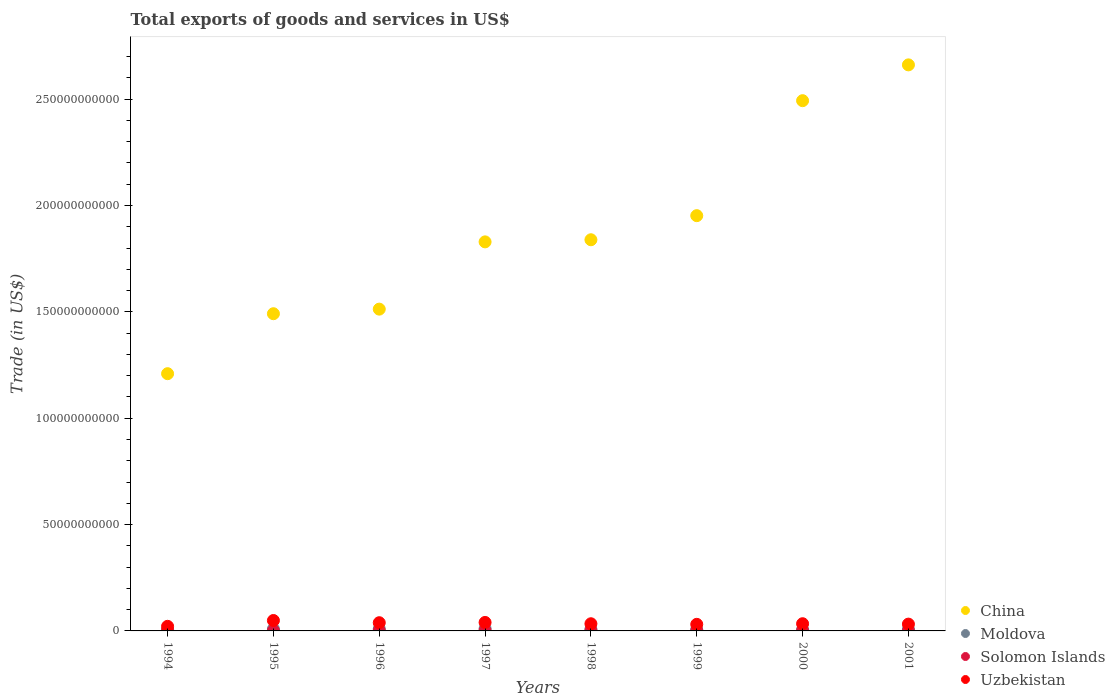Is the number of dotlines equal to the number of legend labels?
Offer a very short reply. Yes. What is the total exports of goods and services in China in 1994?
Your answer should be compact. 1.21e+11. Across all years, what is the maximum total exports of goods and services in China?
Offer a very short reply. 2.66e+11. Across all years, what is the minimum total exports of goods and services in Uzbekistan?
Provide a short and direct response. 2.16e+09. What is the total total exports of goods and services in Solomon Islands in the graph?
Provide a succinct answer. 1.29e+09. What is the difference between the total exports of goods and services in Solomon Islands in 1998 and that in 2000?
Your response must be concise. 6.57e+07. What is the difference between the total exports of goods and services in China in 1997 and the total exports of goods and services in Uzbekistan in 1995?
Offer a very short reply. 1.78e+11. What is the average total exports of goods and services in Uzbekistan per year?
Give a very brief answer. 3.50e+09. In the year 1995, what is the difference between the total exports of goods and services in Uzbekistan and total exports of goods and services in Moldova?
Give a very brief answer. 4.03e+09. In how many years, is the total exports of goods and services in China greater than 240000000000 US$?
Provide a succinct answer. 2. What is the ratio of the total exports of goods and services in Uzbekistan in 1995 to that in 1997?
Your answer should be compact. 1.23. Is the total exports of goods and services in Moldova in 1995 less than that in 1999?
Provide a short and direct response. No. Is the difference between the total exports of goods and services in Uzbekistan in 1994 and 2001 greater than the difference between the total exports of goods and services in Moldova in 1994 and 2001?
Your answer should be very brief. No. What is the difference between the highest and the second highest total exports of goods and services in Moldova?
Make the answer very short. 1.21e+08. What is the difference between the highest and the lowest total exports of goods and services in Solomon Islands?
Your response must be concise. 1.53e+08. In how many years, is the total exports of goods and services in Moldova greater than the average total exports of goods and services in Moldova taken over all years?
Provide a succinct answer. 4. Is it the case that in every year, the sum of the total exports of goods and services in China and total exports of goods and services in Moldova  is greater than the sum of total exports of goods and services in Uzbekistan and total exports of goods and services in Solomon Islands?
Make the answer very short. Yes. Is it the case that in every year, the sum of the total exports of goods and services in Moldova and total exports of goods and services in China  is greater than the total exports of goods and services in Solomon Islands?
Ensure brevity in your answer.  Yes. Does the total exports of goods and services in China monotonically increase over the years?
Your answer should be very brief. Yes. Is the total exports of goods and services in Uzbekistan strictly greater than the total exports of goods and services in Moldova over the years?
Your answer should be very brief. Yes. Is the total exports of goods and services in China strictly less than the total exports of goods and services in Moldova over the years?
Offer a very short reply. No. Does the graph contain any zero values?
Offer a terse response. No. How many legend labels are there?
Provide a succinct answer. 4. What is the title of the graph?
Your answer should be compact. Total exports of goods and services in US$. Does "Lao PDR" appear as one of the legend labels in the graph?
Provide a succinct answer. No. What is the label or title of the Y-axis?
Offer a terse response. Trade (in US$). What is the Trade (in US$) in China in 1994?
Provide a succinct answer. 1.21e+11. What is the Trade (in US$) of Moldova in 1994?
Provide a succinct answer. 6.51e+08. What is the Trade (in US$) of Solomon Islands in 1994?
Your response must be concise. 1.71e+08. What is the Trade (in US$) of Uzbekistan in 1994?
Your response must be concise. 2.16e+09. What is the Trade (in US$) of China in 1995?
Your answer should be very brief. 1.49e+11. What is the Trade (in US$) in Moldova in 1995?
Your response must be concise. 8.65e+08. What is the Trade (in US$) in Solomon Islands in 1995?
Provide a succinct answer. 1.88e+08. What is the Trade (in US$) of Uzbekistan in 1995?
Offer a terse response. 4.90e+09. What is the Trade (in US$) of China in 1996?
Offer a very short reply. 1.51e+11. What is the Trade (in US$) in Moldova in 1996?
Ensure brevity in your answer.  9.37e+08. What is the Trade (in US$) in Solomon Islands in 1996?
Provide a succinct answer. 1.95e+08. What is the Trade (in US$) in Uzbekistan in 1996?
Keep it short and to the point. 3.86e+09. What is the Trade (in US$) in China in 1997?
Your response must be concise. 1.83e+11. What is the Trade (in US$) of Moldova in 1997?
Your answer should be compact. 1.06e+09. What is the Trade (in US$) of Solomon Islands in 1997?
Give a very brief answer. 2.20e+08. What is the Trade (in US$) of Uzbekistan in 1997?
Provide a succinct answer. 3.99e+09. What is the Trade (in US$) in China in 1998?
Your answer should be very brief. 1.84e+11. What is the Trade (in US$) of Moldova in 1998?
Your answer should be compact. 7.96e+08. What is the Trade (in US$) in Solomon Islands in 1998?
Your answer should be very brief. 1.71e+08. What is the Trade (in US$) of Uzbekistan in 1998?
Make the answer very short. 3.37e+09. What is the Trade (in US$) of China in 1999?
Provide a short and direct response. 1.95e+11. What is the Trade (in US$) in Moldova in 1999?
Provide a succinct answer. 6.10e+08. What is the Trade (in US$) in Solomon Islands in 1999?
Provide a short and direct response. 1.72e+08. What is the Trade (in US$) of Uzbekistan in 1999?
Offer a very short reply. 3.10e+09. What is the Trade (in US$) of China in 2000?
Your answer should be very brief. 2.49e+11. What is the Trade (in US$) of Moldova in 2000?
Offer a terse response. 6.41e+08. What is the Trade (in US$) in Solomon Islands in 2000?
Provide a succinct answer. 1.05e+08. What is the Trade (in US$) of Uzbekistan in 2000?
Offer a terse response. 3.38e+09. What is the Trade (in US$) in China in 2001?
Your answer should be very brief. 2.66e+11. What is the Trade (in US$) in Moldova in 2001?
Provide a succinct answer. 7.38e+08. What is the Trade (in US$) of Solomon Islands in 2001?
Give a very brief answer. 6.61e+07. What is the Trade (in US$) in Uzbekistan in 2001?
Make the answer very short. 3.20e+09. Across all years, what is the maximum Trade (in US$) of China?
Provide a succinct answer. 2.66e+11. Across all years, what is the maximum Trade (in US$) of Moldova?
Provide a succinct answer. 1.06e+09. Across all years, what is the maximum Trade (in US$) in Solomon Islands?
Give a very brief answer. 2.20e+08. Across all years, what is the maximum Trade (in US$) in Uzbekistan?
Your answer should be very brief. 4.90e+09. Across all years, what is the minimum Trade (in US$) in China?
Your answer should be compact. 1.21e+11. Across all years, what is the minimum Trade (in US$) in Moldova?
Offer a terse response. 6.10e+08. Across all years, what is the minimum Trade (in US$) of Solomon Islands?
Provide a succinct answer. 6.61e+07. Across all years, what is the minimum Trade (in US$) in Uzbekistan?
Your answer should be very brief. 2.16e+09. What is the total Trade (in US$) in China in the graph?
Provide a succinct answer. 1.50e+12. What is the total Trade (in US$) in Moldova in the graph?
Give a very brief answer. 6.30e+09. What is the total Trade (in US$) of Solomon Islands in the graph?
Keep it short and to the point. 1.29e+09. What is the total Trade (in US$) of Uzbekistan in the graph?
Ensure brevity in your answer.  2.80e+1. What is the difference between the Trade (in US$) of China in 1994 and that in 1995?
Provide a succinct answer. -2.82e+1. What is the difference between the Trade (in US$) in Moldova in 1994 and that in 1995?
Your answer should be compact. -2.14e+08. What is the difference between the Trade (in US$) in Solomon Islands in 1994 and that in 1995?
Provide a short and direct response. -1.73e+07. What is the difference between the Trade (in US$) of Uzbekistan in 1994 and that in 1995?
Offer a very short reply. -2.73e+09. What is the difference between the Trade (in US$) in China in 1994 and that in 1996?
Give a very brief answer. -3.03e+1. What is the difference between the Trade (in US$) of Moldova in 1994 and that in 1996?
Offer a very short reply. -2.86e+08. What is the difference between the Trade (in US$) in Solomon Islands in 1994 and that in 1996?
Give a very brief answer. -2.37e+07. What is the difference between the Trade (in US$) of Uzbekistan in 1994 and that in 1996?
Offer a terse response. -1.70e+09. What is the difference between the Trade (in US$) in China in 1994 and that in 1997?
Offer a very short reply. -6.20e+1. What is the difference between the Trade (in US$) in Moldova in 1994 and that in 1997?
Provide a succinct answer. -4.06e+08. What is the difference between the Trade (in US$) of Solomon Islands in 1994 and that in 1997?
Your response must be concise. -4.88e+07. What is the difference between the Trade (in US$) in Uzbekistan in 1994 and that in 1997?
Make the answer very short. -1.82e+09. What is the difference between the Trade (in US$) in China in 1994 and that in 1998?
Make the answer very short. -6.30e+1. What is the difference between the Trade (in US$) in Moldova in 1994 and that in 1998?
Provide a succinct answer. -1.45e+08. What is the difference between the Trade (in US$) of Solomon Islands in 1994 and that in 1998?
Give a very brief answer. 3.00e+05. What is the difference between the Trade (in US$) in Uzbekistan in 1994 and that in 1998?
Provide a succinct answer. -1.21e+09. What is the difference between the Trade (in US$) of China in 1994 and that in 1999?
Offer a very short reply. -7.43e+1. What is the difference between the Trade (in US$) in Moldova in 1994 and that in 1999?
Provide a short and direct response. 4.12e+07. What is the difference between the Trade (in US$) in Solomon Islands in 1994 and that in 1999?
Ensure brevity in your answer.  -1.28e+06. What is the difference between the Trade (in US$) in Uzbekistan in 1994 and that in 1999?
Provide a short and direct response. -9.35e+08. What is the difference between the Trade (in US$) of China in 1994 and that in 2000?
Your answer should be very brief. -1.28e+11. What is the difference between the Trade (in US$) in Moldova in 1994 and that in 2000?
Your response must be concise. 9.64e+06. What is the difference between the Trade (in US$) of Solomon Islands in 1994 and that in 2000?
Keep it short and to the point. 6.60e+07. What is the difference between the Trade (in US$) in Uzbekistan in 1994 and that in 2000?
Provide a short and direct response. -1.22e+09. What is the difference between the Trade (in US$) in China in 1994 and that in 2001?
Offer a terse response. -1.45e+11. What is the difference between the Trade (in US$) in Moldova in 1994 and that in 2001?
Provide a short and direct response. -8.72e+07. What is the difference between the Trade (in US$) of Solomon Islands in 1994 and that in 2001?
Your answer should be compact. 1.05e+08. What is the difference between the Trade (in US$) in Uzbekistan in 1994 and that in 2001?
Give a very brief answer. -1.04e+09. What is the difference between the Trade (in US$) in China in 1995 and that in 1996?
Offer a very short reply. -2.15e+09. What is the difference between the Trade (in US$) in Moldova in 1995 and that in 1996?
Offer a terse response. -7.18e+07. What is the difference between the Trade (in US$) of Solomon Islands in 1995 and that in 1996?
Offer a terse response. -6.42e+06. What is the difference between the Trade (in US$) of Uzbekistan in 1995 and that in 1996?
Keep it short and to the point. 1.04e+09. What is the difference between the Trade (in US$) in China in 1995 and that in 1997?
Offer a terse response. -3.38e+1. What is the difference between the Trade (in US$) in Moldova in 1995 and that in 1997?
Offer a very short reply. -1.92e+08. What is the difference between the Trade (in US$) in Solomon Islands in 1995 and that in 1997?
Provide a short and direct response. -3.15e+07. What is the difference between the Trade (in US$) in Uzbekistan in 1995 and that in 1997?
Your response must be concise. 9.10e+08. What is the difference between the Trade (in US$) of China in 1995 and that in 1998?
Your answer should be very brief. -3.48e+1. What is the difference between the Trade (in US$) in Moldova in 1995 and that in 1998?
Provide a succinct answer. 6.94e+07. What is the difference between the Trade (in US$) in Solomon Islands in 1995 and that in 1998?
Offer a terse response. 1.76e+07. What is the difference between the Trade (in US$) of Uzbekistan in 1995 and that in 1998?
Provide a succinct answer. 1.53e+09. What is the difference between the Trade (in US$) in China in 1995 and that in 1999?
Offer a very short reply. -4.61e+1. What is the difference between the Trade (in US$) of Moldova in 1995 and that in 1999?
Offer a terse response. 2.55e+08. What is the difference between the Trade (in US$) of Solomon Islands in 1995 and that in 1999?
Provide a succinct answer. 1.60e+07. What is the difference between the Trade (in US$) in Uzbekistan in 1995 and that in 1999?
Keep it short and to the point. 1.80e+09. What is the difference between the Trade (in US$) in China in 1995 and that in 2000?
Ensure brevity in your answer.  -1.00e+11. What is the difference between the Trade (in US$) of Moldova in 1995 and that in 2000?
Keep it short and to the point. 2.24e+08. What is the difference between the Trade (in US$) of Solomon Islands in 1995 and that in 2000?
Provide a short and direct response. 8.33e+07. What is the difference between the Trade (in US$) of Uzbekistan in 1995 and that in 2000?
Offer a very short reply. 1.51e+09. What is the difference between the Trade (in US$) in China in 1995 and that in 2001?
Provide a succinct answer. -1.17e+11. What is the difference between the Trade (in US$) of Moldova in 1995 and that in 2001?
Your answer should be compact. 1.27e+08. What is the difference between the Trade (in US$) of Solomon Islands in 1995 and that in 2001?
Keep it short and to the point. 1.22e+08. What is the difference between the Trade (in US$) in Uzbekistan in 1995 and that in 2001?
Give a very brief answer. 1.70e+09. What is the difference between the Trade (in US$) in China in 1996 and that in 1997?
Provide a short and direct response. -3.16e+1. What is the difference between the Trade (in US$) in Moldova in 1996 and that in 1997?
Make the answer very short. -1.21e+08. What is the difference between the Trade (in US$) in Solomon Islands in 1996 and that in 1997?
Provide a short and direct response. -2.51e+07. What is the difference between the Trade (in US$) of Uzbekistan in 1996 and that in 1997?
Your response must be concise. -1.25e+08. What is the difference between the Trade (in US$) of China in 1996 and that in 1998?
Make the answer very short. -3.26e+1. What is the difference between the Trade (in US$) of Moldova in 1996 and that in 1998?
Offer a very short reply. 1.41e+08. What is the difference between the Trade (in US$) in Solomon Islands in 1996 and that in 1998?
Offer a terse response. 2.40e+07. What is the difference between the Trade (in US$) in Uzbekistan in 1996 and that in 1998?
Your response must be concise. 4.90e+08. What is the difference between the Trade (in US$) of China in 1996 and that in 1999?
Make the answer very short. -4.39e+1. What is the difference between the Trade (in US$) of Moldova in 1996 and that in 1999?
Provide a short and direct response. 3.27e+08. What is the difference between the Trade (in US$) of Solomon Islands in 1996 and that in 1999?
Ensure brevity in your answer.  2.24e+07. What is the difference between the Trade (in US$) in Uzbekistan in 1996 and that in 1999?
Offer a very short reply. 7.63e+08. What is the difference between the Trade (in US$) in China in 1996 and that in 2000?
Offer a very short reply. -9.80e+1. What is the difference between the Trade (in US$) in Moldova in 1996 and that in 2000?
Provide a short and direct response. 2.95e+08. What is the difference between the Trade (in US$) in Solomon Islands in 1996 and that in 2000?
Provide a short and direct response. 8.97e+07. What is the difference between the Trade (in US$) of Uzbekistan in 1996 and that in 2000?
Offer a terse response. 4.79e+08. What is the difference between the Trade (in US$) in China in 1996 and that in 2001?
Make the answer very short. -1.15e+11. What is the difference between the Trade (in US$) of Moldova in 1996 and that in 2001?
Ensure brevity in your answer.  1.99e+08. What is the difference between the Trade (in US$) in Solomon Islands in 1996 and that in 2001?
Your answer should be very brief. 1.28e+08. What is the difference between the Trade (in US$) of Uzbekistan in 1996 and that in 2001?
Your response must be concise. 6.61e+08. What is the difference between the Trade (in US$) of China in 1997 and that in 1998?
Offer a very short reply. -9.96e+08. What is the difference between the Trade (in US$) of Moldova in 1997 and that in 1998?
Your response must be concise. 2.62e+08. What is the difference between the Trade (in US$) of Solomon Islands in 1997 and that in 1998?
Ensure brevity in your answer.  4.91e+07. What is the difference between the Trade (in US$) in Uzbekistan in 1997 and that in 1998?
Provide a short and direct response. 6.15e+08. What is the difference between the Trade (in US$) in China in 1997 and that in 1999?
Provide a short and direct response. -1.23e+1. What is the difference between the Trade (in US$) of Moldova in 1997 and that in 1999?
Your answer should be very brief. 4.48e+08. What is the difference between the Trade (in US$) of Solomon Islands in 1997 and that in 1999?
Your answer should be compact. 4.75e+07. What is the difference between the Trade (in US$) of Uzbekistan in 1997 and that in 1999?
Your answer should be very brief. 8.88e+08. What is the difference between the Trade (in US$) of China in 1997 and that in 2000?
Your response must be concise. -6.64e+1. What is the difference between the Trade (in US$) of Moldova in 1997 and that in 2000?
Your answer should be compact. 4.16e+08. What is the difference between the Trade (in US$) in Solomon Islands in 1997 and that in 2000?
Offer a terse response. 1.15e+08. What is the difference between the Trade (in US$) of Uzbekistan in 1997 and that in 2000?
Ensure brevity in your answer.  6.04e+08. What is the difference between the Trade (in US$) of China in 1997 and that in 2001?
Keep it short and to the point. -8.32e+1. What is the difference between the Trade (in US$) of Moldova in 1997 and that in 2001?
Your response must be concise. 3.19e+08. What is the difference between the Trade (in US$) of Solomon Islands in 1997 and that in 2001?
Your answer should be compact. 1.53e+08. What is the difference between the Trade (in US$) of Uzbekistan in 1997 and that in 2001?
Ensure brevity in your answer.  7.86e+08. What is the difference between the Trade (in US$) of China in 1998 and that in 1999?
Keep it short and to the point. -1.13e+1. What is the difference between the Trade (in US$) of Moldova in 1998 and that in 1999?
Ensure brevity in your answer.  1.86e+08. What is the difference between the Trade (in US$) in Solomon Islands in 1998 and that in 1999?
Provide a short and direct response. -1.58e+06. What is the difference between the Trade (in US$) in Uzbekistan in 1998 and that in 1999?
Offer a terse response. 2.73e+08. What is the difference between the Trade (in US$) of China in 1998 and that in 2000?
Provide a succinct answer. -6.54e+1. What is the difference between the Trade (in US$) of Moldova in 1998 and that in 2000?
Offer a very short reply. 1.54e+08. What is the difference between the Trade (in US$) of Solomon Islands in 1998 and that in 2000?
Offer a terse response. 6.57e+07. What is the difference between the Trade (in US$) of Uzbekistan in 1998 and that in 2000?
Ensure brevity in your answer.  -1.14e+07. What is the difference between the Trade (in US$) of China in 1998 and that in 2001?
Ensure brevity in your answer.  -8.22e+1. What is the difference between the Trade (in US$) in Moldova in 1998 and that in 2001?
Give a very brief answer. 5.75e+07. What is the difference between the Trade (in US$) in Solomon Islands in 1998 and that in 2001?
Your answer should be very brief. 1.04e+08. What is the difference between the Trade (in US$) in Uzbekistan in 1998 and that in 2001?
Provide a succinct answer. 1.71e+08. What is the difference between the Trade (in US$) of China in 1999 and that in 2000?
Make the answer very short. -5.40e+1. What is the difference between the Trade (in US$) of Moldova in 1999 and that in 2000?
Offer a very short reply. -3.15e+07. What is the difference between the Trade (in US$) of Solomon Islands in 1999 and that in 2000?
Offer a terse response. 6.73e+07. What is the difference between the Trade (in US$) of Uzbekistan in 1999 and that in 2000?
Your answer should be very brief. -2.84e+08. What is the difference between the Trade (in US$) of China in 1999 and that in 2001?
Provide a short and direct response. -7.09e+1. What is the difference between the Trade (in US$) of Moldova in 1999 and that in 2001?
Ensure brevity in your answer.  -1.28e+08. What is the difference between the Trade (in US$) of Solomon Islands in 1999 and that in 2001?
Make the answer very short. 1.06e+08. What is the difference between the Trade (in US$) of Uzbekistan in 1999 and that in 2001?
Provide a short and direct response. -1.02e+08. What is the difference between the Trade (in US$) in China in 2000 and that in 2001?
Give a very brief answer. -1.68e+1. What is the difference between the Trade (in US$) of Moldova in 2000 and that in 2001?
Provide a succinct answer. -9.68e+07. What is the difference between the Trade (in US$) in Solomon Islands in 2000 and that in 2001?
Your answer should be very brief. 3.87e+07. What is the difference between the Trade (in US$) of Uzbekistan in 2000 and that in 2001?
Your answer should be compact. 1.82e+08. What is the difference between the Trade (in US$) in China in 1994 and the Trade (in US$) in Moldova in 1995?
Provide a short and direct response. 1.20e+11. What is the difference between the Trade (in US$) of China in 1994 and the Trade (in US$) of Solomon Islands in 1995?
Give a very brief answer. 1.21e+11. What is the difference between the Trade (in US$) in China in 1994 and the Trade (in US$) in Uzbekistan in 1995?
Give a very brief answer. 1.16e+11. What is the difference between the Trade (in US$) in Moldova in 1994 and the Trade (in US$) in Solomon Islands in 1995?
Give a very brief answer. 4.63e+08. What is the difference between the Trade (in US$) in Moldova in 1994 and the Trade (in US$) in Uzbekistan in 1995?
Offer a terse response. -4.25e+09. What is the difference between the Trade (in US$) in Solomon Islands in 1994 and the Trade (in US$) in Uzbekistan in 1995?
Make the answer very short. -4.73e+09. What is the difference between the Trade (in US$) in China in 1994 and the Trade (in US$) in Moldova in 1996?
Your answer should be very brief. 1.20e+11. What is the difference between the Trade (in US$) of China in 1994 and the Trade (in US$) of Solomon Islands in 1996?
Give a very brief answer. 1.21e+11. What is the difference between the Trade (in US$) in China in 1994 and the Trade (in US$) in Uzbekistan in 1996?
Give a very brief answer. 1.17e+11. What is the difference between the Trade (in US$) of Moldova in 1994 and the Trade (in US$) of Solomon Islands in 1996?
Give a very brief answer. 4.56e+08. What is the difference between the Trade (in US$) of Moldova in 1994 and the Trade (in US$) of Uzbekistan in 1996?
Your answer should be very brief. -3.21e+09. What is the difference between the Trade (in US$) in Solomon Islands in 1994 and the Trade (in US$) in Uzbekistan in 1996?
Your answer should be very brief. -3.69e+09. What is the difference between the Trade (in US$) in China in 1994 and the Trade (in US$) in Moldova in 1997?
Offer a very short reply. 1.20e+11. What is the difference between the Trade (in US$) in China in 1994 and the Trade (in US$) in Solomon Islands in 1997?
Your answer should be compact. 1.21e+11. What is the difference between the Trade (in US$) of China in 1994 and the Trade (in US$) of Uzbekistan in 1997?
Your response must be concise. 1.17e+11. What is the difference between the Trade (in US$) in Moldova in 1994 and the Trade (in US$) in Solomon Islands in 1997?
Offer a terse response. 4.31e+08. What is the difference between the Trade (in US$) in Moldova in 1994 and the Trade (in US$) in Uzbekistan in 1997?
Provide a short and direct response. -3.34e+09. What is the difference between the Trade (in US$) of Solomon Islands in 1994 and the Trade (in US$) of Uzbekistan in 1997?
Your response must be concise. -3.82e+09. What is the difference between the Trade (in US$) in China in 1994 and the Trade (in US$) in Moldova in 1998?
Provide a short and direct response. 1.20e+11. What is the difference between the Trade (in US$) in China in 1994 and the Trade (in US$) in Solomon Islands in 1998?
Offer a very short reply. 1.21e+11. What is the difference between the Trade (in US$) of China in 1994 and the Trade (in US$) of Uzbekistan in 1998?
Ensure brevity in your answer.  1.18e+11. What is the difference between the Trade (in US$) of Moldova in 1994 and the Trade (in US$) of Solomon Islands in 1998?
Provide a short and direct response. 4.80e+08. What is the difference between the Trade (in US$) of Moldova in 1994 and the Trade (in US$) of Uzbekistan in 1998?
Ensure brevity in your answer.  -2.72e+09. What is the difference between the Trade (in US$) of Solomon Islands in 1994 and the Trade (in US$) of Uzbekistan in 1998?
Your answer should be compact. -3.20e+09. What is the difference between the Trade (in US$) in China in 1994 and the Trade (in US$) in Moldova in 1999?
Provide a short and direct response. 1.20e+11. What is the difference between the Trade (in US$) in China in 1994 and the Trade (in US$) in Solomon Islands in 1999?
Keep it short and to the point. 1.21e+11. What is the difference between the Trade (in US$) of China in 1994 and the Trade (in US$) of Uzbekistan in 1999?
Ensure brevity in your answer.  1.18e+11. What is the difference between the Trade (in US$) in Moldova in 1994 and the Trade (in US$) in Solomon Islands in 1999?
Offer a very short reply. 4.79e+08. What is the difference between the Trade (in US$) in Moldova in 1994 and the Trade (in US$) in Uzbekistan in 1999?
Offer a terse response. -2.45e+09. What is the difference between the Trade (in US$) of Solomon Islands in 1994 and the Trade (in US$) of Uzbekistan in 1999?
Keep it short and to the point. -2.93e+09. What is the difference between the Trade (in US$) in China in 1994 and the Trade (in US$) in Moldova in 2000?
Your response must be concise. 1.20e+11. What is the difference between the Trade (in US$) in China in 1994 and the Trade (in US$) in Solomon Islands in 2000?
Provide a succinct answer. 1.21e+11. What is the difference between the Trade (in US$) of China in 1994 and the Trade (in US$) of Uzbekistan in 2000?
Your response must be concise. 1.18e+11. What is the difference between the Trade (in US$) of Moldova in 1994 and the Trade (in US$) of Solomon Islands in 2000?
Make the answer very short. 5.46e+08. What is the difference between the Trade (in US$) of Moldova in 1994 and the Trade (in US$) of Uzbekistan in 2000?
Offer a very short reply. -2.73e+09. What is the difference between the Trade (in US$) of Solomon Islands in 1994 and the Trade (in US$) of Uzbekistan in 2000?
Keep it short and to the point. -3.21e+09. What is the difference between the Trade (in US$) of China in 1994 and the Trade (in US$) of Moldova in 2001?
Provide a short and direct response. 1.20e+11. What is the difference between the Trade (in US$) in China in 1994 and the Trade (in US$) in Solomon Islands in 2001?
Offer a terse response. 1.21e+11. What is the difference between the Trade (in US$) in China in 1994 and the Trade (in US$) in Uzbekistan in 2001?
Provide a succinct answer. 1.18e+11. What is the difference between the Trade (in US$) of Moldova in 1994 and the Trade (in US$) of Solomon Islands in 2001?
Provide a short and direct response. 5.85e+08. What is the difference between the Trade (in US$) of Moldova in 1994 and the Trade (in US$) of Uzbekistan in 2001?
Keep it short and to the point. -2.55e+09. What is the difference between the Trade (in US$) of Solomon Islands in 1994 and the Trade (in US$) of Uzbekistan in 2001?
Give a very brief answer. -3.03e+09. What is the difference between the Trade (in US$) in China in 1995 and the Trade (in US$) in Moldova in 1996?
Give a very brief answer. 1.48e+11. What is the difference between the Trade (in US$) in China in 1995 and the Trade (in US$) in Solomon Islands in 1996?
Ensure brevity in your answer.  1.49e+11. What is the difference between the Trade (in US$) in China in 1995 and the Trade (in US$) in Uzbekistan in 1996?
Provide a short and direct response. 1.45e+11. What is the difference between the Trade (in US$) in Moldova in 1995 and the Trade (in US$) in Solomon Islands in 1996?
Your answer should be very brief. 6.70e+08. What is the difference between the Trade (in US$) in Moldova in 1995 and the Trade (in US$) in Uzbekistan in 1996?
Your response must be concise. -3.00e+09. What is the difference between the Trade (in US$) of Solomon Islands in 1995 and the Trade (in US$) of Uzbekistan in 1996?
Offer a terse response. -3.67e+09. What is the difference between the Trade (in US$) in China in 1995 and the Trade (in US$) in Moldova in 1997?
Your answer should be very brief. 1.48e+11. What is the difference between the Trade (in US$) of China in 1995 and the Trade (in US$) of Solomon Islands in 1997?
Keep it short and to the point. 1.49e+11. What is the difference between the Trade (in US$) of China in 1995 and the Trade (in US$) of Uzbekistan in 1997?
Offer a very short reply. 1.45e+11. What is the difference between the Trade (in US$) in Moldova in 1995 and the Trade (in US$) in Solomon Islands in 1997?
Your response must be concise. 6.45e+08. What is the difference between the Trade (in US$) in Moldova in 1995 and the Trade (in US$) in Uzbekistan in 1997?
Offer a terse response. -3.12e+09. What is the difference between the Trade (in US$) in Solomon Islands in 1995 and the Trade (in US$) in Uzbekistan in 1997?
Make the answer very short. -3.80e+09. What is the difference between the Trade (in US$) in China in 1995 and the Trade (in US$) in Moldova in 1998?
Your answer should be compact. 1.48e+11. What is the difference between the Trade (in US$) of China in 1995 and the Trade (in US$) of Solomon Islands in 1998?
Give a very brief answer. 1.49e+11. What is the difference between the Trade (in US$) of China in 1995 and the Trade (in US$) of Uzbekistan in 1998?
Your response must be concise. 1.46e+11. What is the difference between the Trade (in US$) in Moldova in 1995 and the Trade (in US$) in Solomon Islands in 1998?
Provide a short and direct response. 6.95e+08. What is the difference between the Trade (in US$) in Moldova in 1995 and the Trade (in US$) in Uzbekistan in 1998?
Ensure brevity in your answer.  -2.51e+09. What is the difference between the Trade (in US$) of Solomon Islands in 1995 and the Trade (in US$) of Uzbekistan in 1998?
Provide a short and direct response. -3.18e+09. What is the difference between the Trade (in US$) in China in 1995 and the Trade (in US$) in Moldova in 1999?
Provide a succinct answer. 1.49e+11. What is the difference between the Trade (in US$) of China in 1995 and the Trade (in US$) of Solomon Islands in 1999?
Your answer should be very brief. 1.49e+11. What is the difference between the Trade (in US$) of China in 1995 and the Trade (in US$) of Uzbekistan in 1999?
Ensure brevity in your answer.  1.46e+11. What is the difference between the Trade (in US$) in Moldova in 1995 and the Trade (in US$) in Solomon Islands in 1999?
Make the answer very short. 6.93e+08. What is the difference between the Trade (in US$) in Moldova in 1995 and the Trade (in US$) in Uzbekistan in 1999?
Keep it short and to the point. -2.23e+09. What is the difference between the Trade (in US$) of Solomon Islands in 1995 and the Trade (in US$) of Uzbekistan in 1999?
Provide a short and direct response. -2.91e+09. What is the difference between the Trade (in US$) in China in 1995 and the Trade (in US$) in Moldova in 2000?
Provide a short and direct response. 1.48e+11. What is the difference between the Trade (in US$) of China in 1995 and the Trade (in US$) of Solomon Islands in 2000?
Provide a succinct answer. 1.49e+11. What is the difference between the Trade (in US$) of China in 1995 and the Trade (in US$) of Uzbekistan in 2000?
Provide a succinct answer. 1.46e+11. What is the difference between the Trade (in US$) in Moldova in 1995 and the Trade (in US$) in Solomon Islands in 2000?
Ensure brevity in your answer.  7.60e+08. What is the difference between the Trade (in US$) of Moldova in 1995 and the Trade (in US$) of Uzbekistan in 2000?
Keep it short and to the point. -2.52e+09. What is the difference between the Trade (in US$) of Solomon Islands in 1995 and the Trade (in US$) of Uzbekistan in 2000?
Keep it short and to the point. -3.20e+09. What is the difference between the Trade (in US$) of China in 1995 and the Trade (in US$) of Moldova in 2001?
Offer a very short reply. 1.48e+11. What is the difference between the Trade (in US$) of China in 1995 and the Trade (in US$) of Solomon Islands in 2001?
Offer a very short reply. 1.49e+11. What is the difference between the Trade (in US$) in China in 1995 and the Trade (in US$) in Uzbekistan in 2001?
Your answer should be very brief. 1.46e+11. What is the difference between the Trade (in US$) of Moldova in 1995 and the Trade (in US$) of Solomon Islands in 2001?
Ensure brevity in your answer.  7.99e+08. What is the difference between the Trade (in US$) in Moldova in 1995 and the Trade (in US$) in Uzbekistan in 2001?
Provide a short and direct response. -2.34e+09. What is the difference between the Trade (in US$) in Solomon Islands in 1995 and the Trade (in US$) in Uzbekistan in 2001?
Keep it short and to the point. -3.01e+09. What is the difference between the Trade (in US$) of China in 1996 and the Trade (in US$) of Moldova in 1997?
Your answer should be very brief. 1.50e+11. What is the difference between the Trade (in US$) in China in 1996 and the Trade (in US$) in Solomon Islands in 1997?
Keep it short and to the point. 1.51e+11. What is the difference between the Trade (in US$) of China in 1996 and the Trade (in US$) of Uzbekistan in 1997?
Provide a succinct answer. 1.47e+11. What is the difference between the Trade (in US$) in Moldova in 1996 and the Trade (in US$) in Solomon Islands in 1997?
Your answer should be compact. 7.17e+08. What is the difference between the Trade (in US$) of Moldova in 1996 and the Trade (in US$) of Uzbekistan in 1997?
Make the answer very short. -3.05e+09. What is the difference between the Trade (in US$) of Solomon Islands in 1996 and the Trade (in US$) of Uzbekistan in 1997?
Ensure brevity in your answer.  -3.79e+09. What is the difference between the Trade (in US$) in China in 1996 and the Trade (in US$) in Moldova in 1998?
Provide a short and direct response. 1.50e+11. What is the difference between the Trade (in US$) in China in 1996 and the Trade (in US$) in Solomon Islands in 1998?
Provide a succinct answer. 1.51e+11. What is the difference between the Trade (in US$) in China in 1996 and the Trade (in US$) in Uzbekistan in 1998?
Offer a very short reply. 1.48e+11. What is the difference between the Trade (in US$) of Moldova in 1996 and the Trade (in US$) of Solomon Islands in 1998?
Offer a terse response. 7.66e+08. What is the difference between the Trade (in US$) in Moldova in 1996 and the Trade (in US$) in Uzbekistan in 1998?
Offer a terse response. -2.44e+09. What is the difference between the Trade (in US$) of Solomon Islands in 1996 and the Trade (in US$) of Uzbekistan in 1998?
Offer a very short reply. -3.18e+09. What is the difference between the Trade (in US$) of China in 1996 and the Trade (in US$) of Moldova in 1999?
Your answer should be compact. 1.51e+11. What is the difference between the Trade (in US$) in China in 1996 and the Trade (in US$) in Solomon Islands in 1999?
Your answer should be very brief. 1.51e+11. What is the difference between the Trade (in US$) of China in 1996 and the Trade (in US$) of Uzbekistan in 1999?
Keep it short and to the point. 1.48e+11. What is the difference between the Trade (in US$) in Moldova in 1996 and the Trade (in US$) in Solomon Islands in 1999?
Provide a succinct answer. 7.65e+08. What is the difference between the Trade (in US$) of Moldova in 1996 and the Trade (in US$) of Uzbekistan in 1999?
Keep it short and to the point. -2.16e+09. What is the difference between the Trade (in US$) of Solomon Islands in 1996 and the Trade (in US$) of Uzbekistan in 1999?
Provide a succinct answer. -2.90e+09. What is the difference between the Trade (in US$) in China in 1996 and the Trade (in US$) in Moldova in 2000?
Offer a very short reply. 1.51e+11. What is the difference between the Trade (in US$) of China in 1996 and the Trade (in US$) of Solomon Islands in 2000?
Your response must be concise. 1.51e+11. What is the difference between the Trade (in US$) of China in 1996 and the Trade (in US$) of Uzbekistan in 2000?
Ensure brevity in your answer.  1.48e+11. What is the difference between the Trade (in US$) of Moldova in 1996 and the Trade (in US$) of Solomon Islands in 2000?
Ensure brevity in your answer.  8.32e+08. What is the difference between the Trade (in US$) in Moldova in 1996 and the Trade (in US$) in Uzbekistan in 2000?
Give a very brief answer. -2.45e+09. What is the difference between the Trade (in US$) of Solomon Islands in 1996 and the Trade (in US$) of Uzbekistan in 2000?
Keep it short and to the point. -3.19e+09. What is the difference between the Trade (in US$) of China in 1996 and the Trade (in US$) of Moldova in 2001?
Your response must be concise. 1.51e+11. What is the difference between the Trade (in US$) of China in 1996 and the Trade (in US$) of Solomon Islands in 2001?
Your answer should be compact. 1.51e+11. What is the difference between the Trade (in US$) of China in 1996 and the Trade (in US$) of Uzbekistan in 2001?
Your answer should be compact. 1.48e+11. What is the difference between the Trade (in US$) of Moldova in 1996 and the Trade (in US$) of Solomon Islands in 2001?
Your answer should be very brief. 8.71e+08. What is the difference between the Trade (in US$) in Moldova in 1996 and the Trade (in US$) in Uzbekistan in 2001?
Offer a terse response. -2.26e+09. What is the difference between the Trade (in US$) of Solomon Islands in 1996 and the Trade (in US$) of Uzbekistan in 2001?
Provide a short and direct response. -3.01e+09. What is the difference between the Trade (in US$) of China in 1997 and the Trade (in US$) of Moldova in 1998?
Your answer should be very brief. 1.82e+11. What is the difference between the Trade (in US$) in China in 1997 and the Trade (in US$) in Solomon Islands in 1998?
Give a very brief answer. 1.83e+11. What is the difference between the Trade (in US$) in China in 1997 and the Trade (in US$) in Uzbekistan in 1998?
Your response must be concise. 1.80e+11. What is the difference between the Trade (in US$) in Moldova in 1997 and the Trade (in US$) in Solomon Islands in 1998?
Give a very brief answer. 8.87e+08. What is the difference between the Trade (in US$) in Moldova in 1997 and the Trade (in US$) in Uzbekistan in 1998?
Your response must be concise. -2.31e+09. What is the difference between the Trade (in US$) in Solomon Islands in 1997 and the Trade (in US$) in Uzbekistan in 1998?
Give a very brief answer. -3.15e+09. What is the difference between the Trade (in US$) of China in 1997 and the Trade (in US$) of Moldova in 1999?
Your answer should be very brief. 1.82e+11. What is the difference between the Trade (in US$) in China in 1997 and the Trade (in US$) in Solomon Islands in 1999?
Offer a very short reply. 1.83e+11. What is the difference between the Trade (in US$) in China in 1997 and the Trade (in US$) in Uzbekistan in 1999?
Offer a terse response. 1.80e+11. What is the difference between the Trade (in US$) of Moldova in 1997 and the Trade (in US$) of Solomon Islands in 1999?
Your response must be concise. 8.85e+08. What is the difference between the Trade (in US$) of Moldova in 1997 and the Trade (in US$) of Uzbekistan in 1999?
Provide a succinct answer. -2.04e+09. What is the difference between the Trade (in US$) of Solomon Islands in 1997 and the Trade (in US$) of Uzbekistan in 1999?
Provide a succinct answer. -2.88e+09. What is the difference between the Trade (in US$) in China in 1997 and the Trade (in US$) in Moldova in 2000?
Make the answer very short. 1.82e+11. What is the difference between the Trade (in US$) of China in 1997 and the Trade (in US$) of Solomon Islands in 2000?
Provide a succinct answer. 1.83e+11. What is the difference between the Trade (in US$) in China in 1997 and the Trade (in US$) in Uzbekistan in 2000?
Keep it short and to the point. 1.80e+11. What is the difference between the Trade (in US$) in Moldova in 1997 and the Trade (in US$) in Solomon Islands in 2000?
Your response must be concise. 9.53e+08. What is the difference between the Trade (in US$) in Moldova in 1997 and the Trade (in US$) in Uzbekistan in 2000?
Provide a short and direct response. -2.33e+09. What is the difference between the Trade (in US$) of Solomon Islands in 1997 and the Trade (in US$) of Uzbekistan in 2000?
Make the answer very short. -3.16e+09. What is the difference between the Trade (in US$) of China in 1997 and the Trade (in US$) of Moldova in 2001?
Your answer should be compact. 1.82e+11. What is the difference between the Trade (in US$) in China in 1997 and the Trade (in US$) in Solomon Islands in 2001?
Ensure brevity in your answer.  1.83e+11. What is the difference between the Trade (in US$) in China in 1997 and the Trade (in US$) in Uzbekistan in 2001?
Provide a succinct answer. 1.80e+11. What is the difference between the Trade (in US$) in Moldova in 1997 and the Trade (in US$) in Solomon Islands in 2001?
Your response must be concise. 9.91e+08. What is the difference between the Trade (in US$) of Moldova in 1997 and the Trade (in US$) of Uzbekistan in 2001?
Offer a terse response. -2.14e+09. What is the difference between the Trade (in US$) in Solomon Islands in 1997 and the Trade (in US$) in Uzbekistan in 2001?
Your answer should be very brief. -2.98e+09. What is the difference between the Trade (in US$) in China in 1998 and the Trade (in US$) in Moldova in 1999?
Give a very brief answer. 1.83e+11. What is the difference between the Trade (in US$) of China in 1998 and the Trade (in US$) of Solomon Islands in 1999?
Give a very brief answer. 1.84e+11. What is the difference between the Trade (in US$) in China in 1998 and the Trade (in US$) in Uzbekistan in 1999?
Give a very brief answer. 1.81e+11. What is the difference between the Trade (in US$) in Moldova in 1998 and the Trade (in US$) in Solomon Islands in 1999?
Offer a very short reply. 6.24e+08. What is the difference between the Trade (in US$) of Moldova in 1998 and the Trade (in US$) of Uzbekistan in 1999?
Your answer should be very brief. -2.30e+09. What is the difference between the Trade (in US$) in Solomon Islands in 1998 and the Trade (in US$) in Uzbekistan in 1999?
Your answer should be very brief. -2.93e+09. What is the difference between the Trade (in US$) of China in 1998 and the Trade (in US$) of Moldova in 2000?
Offer a very short reply. 1.83e+11. What is the difference between the Trade (in US$) in China in 1998 and the Trade (in US$) in Solomon Islands in 2000?
Give a very brief answer. 1.84e+11. What is the difference between the Trade (in US$) of China in 1998 and the Trade (in US$) of Uzbekistan in 2000?
Ensure brevity in your answer.  1.80e+11. What is the difference between the Trade (in US$) in Moldova in 1998 and the Trade (in US$) in Solomon Islands in 2000?
Offer a very short reply. 6.91e+08. What is the difference between the Trade (in US$) of Moldova in 1998 and the Trade (in US$) of Uzbekistan in 2000?
Offer a very short reply. -2.59e+09. What is the difference between the Trade (in US$) of Solomon Islands in 1998 and the Trade (in US$) of Uzbekistan in 2000?
Your response must be concise. -3.21e+09. What is the difference between the Trade (in US$) in China in 1998 and the Trade (in US$) in Moldova in 2001?
Keep it short and to the point. 1.83e+11. What is the difference between the Trade (in US$) in China in 1998 and the Trade (in US$) in Solomon Islands in 2001?
Provide a short and direct response. 1.84e+11. What is the difference between the Trade (in US$) of China in 1998 and the Trade (in US$) of Uzbekistan in 2001?
Ensure brevity in your answer.  1.81e+11. What is the difference between the Trade (in US$) in Moldova in 1998 and the Trade (in US$) in Solomon Islands in 2001?
Offer a terse response. 7.29e+08. What is the difference between the Trade (in US$) of Moldova in 1998 and the Trade (in US$) of Uzbekistan in 2001?
Offer a terse response. -2.41e+09. What is the difference between the Trade (in US$) of Solomon Islands in 1998 and the Trade (in US$) of Uzbekistan in 2001?
Your response must be concise. -3.03e+09. What is the difference between the Trade (in US$) in China in 1999 and the Trade (in US$) in Moldova in 2000?
Your answer should be very brief. 1.95e+11. What is the difference between the Trade (in US$) of China in 1999 and the Trade (in US$) of Solomon Islands in 2000?
Offer a very short reply. 1.95e+11. What is the difference between the Trade (in US$) in China in 1999 and the Trade (in US$) in Uzbekistan in 2000?
Your answer should be very brief. 1.92e+11. What is the difference between the Trade (in US$) of Moldova in 1999 and the Trade (in US$) of Solomon Islands in 2000?
Offer a terse response. 5.05e+08. What is the difference between the Trade (in US$) of Moldova in 1999 and the Trade (in US$) of Uzbekistan in 2000?
Make the answer very short. -2.77e+09. What is the difference between the Trade (in US$) in Solomon Islands in 1999 and the Trade (in US$) in Uzbekistan in 2000?
Provide a short and direct response. -3.21e+09. What is the difference between the Trade (in US$) of China in 1999 and the Trade (in US$) of Moldova in 2001?
Your answer should be very brief. 1.94e+11. What is the difference between the Trade (in US$) of China in 1999 and the Trade (in US$) of Solomon Islands in 2001?
Keep it short and to the point. 1.95e+11. What is the difference between the Trade (in US$) of China in 1999 and the Trade (in US$) of Uzbekistan in 2001?
Your answer should be very brief. 1.92e+11. What is the difference between the Trade (in US$) in Moldova in 1999 and the Trade (in US$) in Solomon Islands in 2001?
Your answer should be compact. 5.44e+08. What is the difference between the Trade (in US$) in Moldova in 1999 and the Trade (in US$) in Uzbekistan in 2001?
Your response must be concise. -2.59e+09. What is the difference between the Trade (in US$) of Solomon Islands in 1999 and the Trade (in US$) of Uzbekistan in 2001?
Offer a terse response. -3.03e+09. What is the difference between the Trade (in US$) in China in 2000 and the Trade (in US$) in Moldova in 2001?
Offer a terse response. 2.49e+11. What is the difference between the Trade (in US$) in China in 2000 and the Trade (in US$) in Solomon Islands in 2001?
Your answer should be very brief. 2.49e+11. What is the difference between the Trade (in US$) of China in 2000 and the Trade (in US$) of Uzbekistan in 2001?
Give a very brief answer. 2.46e+11. What is the difference between the Trade (in US$) of Moldova in 2000 and the Trade (in US$) of Solomon Islands in 2001?
Your response must be concise. 5.75e+08. What is the difference between the Trade (in US$) of Moldova in 2000 and the Trade (in US$) of Uzbekistan in 2001?
Make the answer very short. -2.56e+09. What is the difference between the Trade (in US$) of Solomon Islands in 2000 and the Trade (in US$) of Uzbekistan in 2001?
Keep it short and to the point. -3.10e+09. What is the average Trade (in US$) of China per year?
Provide a succinct answer. 1.87e+11. What is the average Trade (in US$) in Moldova per year?
Your answer should be very brief. 7.87e+08. What is the average Trade (in US$) in Solomon Islands per year?
Make the answer very short. 1.61e+08. What is the average Trade (in US$) of Uzbekistan per year?
Keep it short and to the point. 3.50e+09. In the year 1994, what is the difference between the Trade (in US$) in China and Trade (in US$) in Moldova?
Your answer should be compact. 1.20e+11. In the year 1994, what is the difference between the Trade (in US$) in China and Trade (in US$) in Solomon Islands?
Keep it short and to the point. 1.21e+11. In the year 1994, what is the difference between the Trade (in US$) in China and Trade (in US$) in Uzbekistan?
Provide a short and direct response. 1.19e+11. In the year 1994, what is the difference between the Trade (in US$) in Moldova and Trade (in US$) in Solomon Islands?
Offer a very short reply. 4.80e+08. In the year 1994, what is the difference between the Trade (in US$) of Moldova and Trade (in US$) of Uzbekistan?
Keep it short and to the point. -1.51e+09. In the year 1994, what is the difference between the Trade (in US$) in Solomon Islands and Trade (in US$) in Uzbekistan?
Offer a terse response. -1.99e+09. In the year 1995, what is the difference between the Trade (in US$) of China and Trade (in US$) of Moldova?
Ensure brevity in your answer.  1.48e+11. In the year 1995, what is the difference between the Trade (in US$) in China and Trade (in US$) in Solomon Islands?
Provide a short and direct response. 1.49e+11. In the year 1995, what is the difference between the Trade (in US$) of China and Trade (in US$) of Uzbekistan?
Provide a short and direct response. 1.44e+11. In the year 1995, what is the difference between the Trade (in US$) in Moldova and Trade (in US$) in Solomon Islands?
Your answer should be very brief. 6.77e+08. In the year 1995, what is the difference between the Trade (in US$) of Moldova and Trade (in US$) of Uzbekistan?
Keep it short and to the point. -4.03e+09. In the year 1995, what is the difference between the Trade (in US$) in Solomon Islands and Trade (in US$) in Uzbekistan?
Offer a very short reply. -4.71e+09. In the year 1996, what is the difference between the Trade (in US$) in China and Trade (in US$) in Moldova?
Offer a terse response. 1.50e+11. In the year 1996, what is the difference between the Trade (in US$) in China and Trade (in US$) in Solomon Islands?
Ensure brevity in your answer.  1.51e+11. In the year 1996, what is the difference between the Trade (in US$) in China and Trade (in US$) in Uzbekistan?
Offer a terse response. 1.47e+11. In the year 1996, what is the difference between the Trade (in US$) in Moldova and Trade (in US$) in Solomon Islands?
Keep it short and to the point. 7.42e+08. In the year 1996, what is the difference between the Trade (in US$) of Moldova and Trade (in US$) of Uzbekistan?
Give a very brief answer. -2.93e+09. In the year 1996, what is the difference between the Trade (in US$) in Solomon Islands and Trade (in US$) in Uzbekistan?
Provide a short and direct response. -3.67e+09. In the year 1997, what is the difference between the Trade (in US$) of China and Trade (in US$) of Moldova?
Make the answer very short. 1.82e+11. In the year 1997, what is the difference between the Trade (in US$) of China and Trade (in US$) of Solomon Islands?
Keep it short and to the point. 1.83e+11. In the year 1997, what is the difference between the Trade (in US$) in China and Trade (in US$) in Uzbekistan?
Give a very brief answer. 1.79e+11. In the year 1997, what is the difference between the Trade (in US$) in Moldova and Trade (in US$) in Solomon Islands?
Keep it short and to the point. 8.38e+08. In the year 1997, what is the difference between the Trade (in US$) of Moldova and Trade (in US$) of Uzbekistan?
Provide a succinct answer. -2.93e+09. In the year 1997, what is the difference between the Trade (in US$) in Solomon Islands and Trade (in US$) in Uzbekistan?
Make the answer very short. -3.77e+09. In the year 1998, what is the difference between the Trade (in US$) of China and Trade (in US$) of Moldova?
Give a very brief answer. 1.83e+11. In the year 1998, what is the difference between the Trade (in US$) of China and Trade (in US$) of Solomon Islands?
Ensure brevity in your answer.  1.84e+11. In the year 1998, what is the difference between the Trade (in US$) in China and Trade (in US$) in Uzbekistan?
Keep it short and to the point. 1.81e+11. In the year 1998, what is the difference between the Trade (in US$) of Moldova and Trade (in US$) of Solomon Islands?
Ensure brevity in your answer.  6.25e+08. In the year 1998, what is the difference between the Trade (in US$) of Moldova and Trade (in US$) of Uzbekistan?
Keep it short and to the point. -2.58e+09. In the year 1998, what is the difference between the Trade (in US$) in Solomon Islands and Trade (in US$) in Uzbekistan?
Your answer should be very brief. -3.20e+09. In the year 1999, what is the difference between the Trade (in US$) in China and Trade (in US$) in Moldova?
Provide a succinct answer. 1.95e+11. In the year 1999, what is the difference between the Trade (in US$) in China and Trade (in US$) in Solomon Islands?
Your answer should be compact. 1.95e+11. In the year 1999, what is the difference between the Trade (in US$) in China and Trade (in US$) in Uzbekistan?
Offer a terse response. 1.92e+11. In the year 1999, what is the difference between the Trade (in US$) of Moldova and Trade (in US$) of Solomon Islands?
Offer a terse response. 4.38e+08. In the year 1999, what is the difference between the Trade (in US$) of Moldova and Trade (in US$) of Uzbekistan?
Provide a succinct answer. -2.49e+09. In the year 1999, what is the difference between the Trade (in US$) in Solomon Islands and Trade (in US$) in Uzbekistan?
Ensure brevity in your answer.  -2.93e+09. In the year 2000, what is the difference between the Trade (in US$) in China and Trade (in US$) in Moldova?
Keep it short and to the point. 2.49e+11. In the year 2000, what is the difference between the Trade (in US$) of China and Trade (in US$) of Solomon Islands?
Give a very brief answer. 2.49e+11. In the year 2000, what is the difference between the Trade (in US$) in China and Trade (in US$) in Uzbekistan?
Give a very brief answer. 2.46e+11. In the year 2000, what is the difference between the Trade (in US$) of Moldova and Trade (in US$) of Solomon Islands?
Offer a very short reply. 5.37e+08. In the year 2000, what is the difference between the Trade (in US$) in Moldova and Trade (in US$) in Uzbekistan?
Ensure brevity in your answer.  -2.74e+09. In the year 2000, what is the difference between the Trade (in US$) of Solomon Islands and Trade (in US$) of Uzbekistan?
Your answer should be compact. -3.28e+09. In the year 2001, what is the difference between the Trade (in US$) in China and Trade (in US$) in Moldova?
Your answer should be very brief. 2.65e+11. In the year 2001, what is the difference between the Trade (in US$) in China and Trade (in US$) in Solomon Islands?
Offer a terse response. 2.66e+11. In the year 2001, what is the difference between the Trade (in US$) of China and Trade (in US$) of Uzbekistan?
Your answer should be compact. 2.63e+11. In the year 2001, what is the difference between the Trade (in US$) in Moldova and Trade (in US$) in Solomon Islands?
Offer a terse response. 6.72e+08. In the year 2001, what is the difference between the Trade (in US$) in Moldova and Trade (in US$) in Uzbekistan?
Offer a very short reply. -2.46e+09. In the year 2001, what is the difference between the Trade (in US$) in Solomon Islands and Trade (in US$) in Uzbekistan?
Provide a short and direct response. -3.13e+09. What is the ratio of the Trade (in US$) in China in 1994 to that in 1995?
Keep it short and to the point. 0.81. What is the ratio of the Trade (in US$) of Moldova in 1994 to that in 1995?
Provide a short and direct response. 0.75. What is the ratio of the Trade (in US$) in Solomon Islands in 1994 to that in 1995?
Offer a terse response. 0.91. What is the ratio of the Trade (in US$) of Uzbekistan in 1994 to that in 1995?
Keep it short and to the point. 0.44. What is the ratio of the Trade (in US$) of China in 1994 to that in 1996?
Your answer should be very brief. 0.8. What is the ratio of the Trade (in US$) in Moldova in 1994 to that in 1996?
Offer a terse response. 0.69. What is the ratio of the Trade (in US$) in Solomon Islands in 1994 to that in 1996?
Ensure brevity in your answer.  0.88. What is the ratio of the Trade (in US$) of Uzbekistan in 1994 to that in 1996?
Your answer should be very brief. 0.56. What is the ratio of the Trade (in US$) of China in 1994 to that in 1997?
Offer a very short reply. 0.66. What is the ratio of the Trade (in US$) in Moldova in 1994 to that in 1997?
Provide a short and direct response. 0.62. What is the ratio of the Trade (in US$) of Solomon Islands in 1994 to that in 1997?
Offer a very short reply. 0.78. What is the ratio of the Trade (in US$) in Uzbekistan in 1994 to that in 1997?
Offer a very short reply. 0.54. What is the ratio of the Trade (in US$) in China in 1994 to that in 1998?
Ensure brevity in your answer.  0.66. What is the ratio of the Trade (in US$) of Moldova in 1994 to that in 1998?
Offer a very short reply. 0.82. What is the ratio of the Trade (in US$) in Solomon Islands in 1994 to that in 1998?
Make the answer very short. 1. What is the ratio of the Trade (in US$) in Uzbekistan in 1994 to that in 1998?
Make the answer very short. 0.64. What is the ratio of the Trade (in US$) in China in 1994 to that in 1999?
Make the answer very short. 0.62. What is the ratio of the Trade (in US$) in Moldova in 1994 to that in 1999?
Provide a succinct answer. 1.07. What is the ratio of the Trade (in US$) of Solomon Islands in 1994 to that in 1999?
Your answer should be very brief. 0.99. What is the ratio of the Trade (in US$) in Uzbekistan in 1994 to that in 1999?
Keep it short and to the point. 0.7. What is the ratio of the Trade (in US$) of China in 1994 to that in 2000?
Your answer should be compact. 0.49. What is the ratio of the Trade (in US$) of Solomon Islands in 1994 to that in 2000?
Offer a very short reply. 1.63. What is the ratio of the Trade (in US$) in Uzbekistan in 1994 to that in 2000?
Ensure brevity in your answer.  0.64. What is the ratio of the Trade (in US$) of China in 1994 to that in 2001?
Your answer should be compact. 0.45. What is the ratio of the Trade (in US$) of Moldova in 1994 to that in 2001?
Offer a terse response. 0.88. What is the ratio of the Trade (in US$) in Solomon Islands in 1994 to that in 2001?
Provide a short and direct response. 2.58. What is the ratio of the Trade (in US$) in Uzbekistan in 1994 to that in 2001?
Offer a very short reply. 0.68. What is the ratio of the Trade (in US$) in China in 1995 to that in 1996?
Provide a succinct answer. 0.99. What is the ratio of the Trade (in US$) of Moldova in 1995 to that in 1996?
Your response must be concise. 0.92. What is the ratio of the Trade (in US$) in Solomon Islands in 1995 to that in 1996?
Your response must be concise. 0.97. What is the ratio of the Trade (in US$) of Uzbekistan in 1995 to that in 1996?
Your answer should be very brief. 1.27. What is the ratio of the Trade (in US$) in China in 1995 to that in 1997?
Make the answer very short. 0.82. What is the ratio of the Trade (in US$) of Moldova in 1995 to that in 1997?
Offer a terse response. 0.82. What is the ratio of the Trade (in US$) of Solomon Islands in 1995 to that in 1997?
Your response must be concise. 0.86. What is the ratio of the Trade (in US$) of Uzbekistan in 1995 to that in 1997?
Make the answer very short. 1.23. What is the ratio of the Trade (in US$) in China in 1995 to that in 1998?
Make the answer very short. 0.81. What is the ratio of the Trade (in US$) of Moldova in 1995 to that in 1998?
Provide a succinct answer. 1.09. What is the ratio of the Trade (in US$) of Solomon Islands in 1995 to that in 1998?
Your answer should be compact. 1.1. What is the ratio of the Trade (in US$) of Uzbekistan in 1995 to that in 1998?
Provide a succinct answer. 1.45. What is the ratio of the Trade (in US$) in China in 1995 to that in 1999?
Provide a short and direct response. 0.76. What is the ratio of the Trade (in US$) of Moldova in 1995 to that in 1999?
Provide a succinct answer. 1.42. What is the ratio of the Trade (in US$) in Solomon Islands in 1995 to that in 1999?
Offer a very short reply. 1.09. What is the ratio of the Trade (in US$) of Uzbekistan in 1995 to that in 1999?
Ensure brevity in your answer.  1.58. What is the ratio of the Trade (in US$) of China in 1995 to that in 2000?
Keep it short and to the point. 0.6. What is the ratio of the Trade (in US$) of Moldova in 1995 to that in 2000?
Give a very brief answer. 1.35. What is the ratio of the Trade (in US$) of Solomon Islands in 1995 to that in 2000?
Make the answer very short. 1.79. What is the ratio of the Trade (in US$) of Uzbekistan in 1995 to that in 2000?
Offer a terse response. 1.45. What is the ratio of the Trade (in US$) of China in 1995 to that in 2001?
Offer a very short reply. 0.56. What is the ratio of the Trade (in US$) of Moldova in 1995 to that in 2001?
Make the answer very short. 1.17. What is the ratio of the Trade (in US$) in Solomon Islands in 1995 to that in 2001?
Your answer should be very brief. 2.84. What is the ratio of the Trade (in US$) of Uzbekistan in 1995 to that in 2001?
Offer a terse response. 1.53. What is the ratio of the Trade (in US$) in China in 1996 to that in 1997?
Keep it short and to the point. 0.83. What is the ratio of the Trade (in US$) in Moldova in 1996 to that in 1997?
Make the answer very short. 0.89. What is the ratio of the Trade (in US$) of Solomon Islands in 1996 to that in 1997?
Give a very brief answer. 0.89. What is the ratio of the Trade (in US$) in Uzbekistan in 1996 to that in 1997?
Provide a succinct answer. 0.97. What is the ratio of the Trade (in US$) in China in 1996 to that in 1998?
Keep it short and to the point. 0.82. What is the ratio of the Trade (in US$) in Moldova in 1996 to that in 1998?
Keep it short and to the point. 1.18. What is the ratio of the Trade (in US$) in Solomon Islands in 1996 to that in 1998?
Keep it short and to the point. 1.14. What is the ratio of the Trade (in US$) of Uzbekistan in 1996 to that in 1998?
Offer a very short reply. 1.15. What is the ratio of the Trade (in US$) of China in 1996 to that in 1999?
Ensure brevity in your answer.  0.77. What is the ratio of the Trade (in US$) in Moldova in 1996 to that in 1999?
Provide a short and direct response. 1.54. What is the ratio of the Trade (in US$) in Solomon Islands in 1996 to that in 1999?
Provide a succinct answer. 1.13. What is the ratio of the Trade (in US$) of Uzbekistan in 1996 to that in 1999?
Your response must be concise. 1.25. What is the ratio of the Trade (in US$) of China in 1996 to that in 2000?
Keep it short and to the point. 0.61. What is the ratio of the Trade (in US$) of Moldova in 1996 to that in 2000?
Your response must be concise. 1.46. What is the ratio of the Trade (in US$) of Solomon Islands in 1996 to that in 2000?
Your answer should be very brief. 1.86. What is the ratio of the Trade (in US$) in Uzbekistan in 1996 to that in 2000?
Your response must be concise. 1.14. What is the ratio of the Trade (in US$) in China in 1996 to that in 2001?
Your response must be concise. 0.57. What is the ratio of the Trade (in US$) of Moldova in 1996 to that in 2001?
Your response must be concise. 1.27. What is the ratio of the Trade (in US$) of Solomon Islands in 1996 to that in 2001?
Ensure brevity in your answer.  2.94. What is the ratio of the Trade (in US$) in Uzbekistan in 1996 to that in 2001?
Keep it short and to the point. 1.21. What is the ratio of the Trade (in US$) in Moldova in 1997 to that in 1998?
Your answer should be very brief. 1.33. What is the ratio of the Trade (in US$) of Solomon Islands in 1997 to that in 1998?
Give a very brief answer. 1.29. What is the ratio of the Trade (in US$) in Uzbekistan in 1997 to that in 1998?
Offer a very short reply. 1.18. What is the ratio of the Trade (in US$) in China in 1997 to that in 1999?
Offer a terse response. 0.94. What is the ratio of the Trade (in US$) of Moldova in 1997 to that in 1999?
Keep it short and to the point. 1.73. What is the ratio of the Trade (in US$) of Solomon Islands in 1997 to that in 1999?
Keep it short and to the point. 1.28. What is the ratio of the Trade (in US$) in Uzbekistan in 1997 to that in 1999?
Ensure brevity in your answer.  1.29. What is the ratio of the Trade (in US$) in China in 1997 to that in 2000?
Your response must be concise. 0.73. What is the ratio of the Trade (in US$) of Moldova in 1997 to that in 2000?
Ensure brevity in your answer.  1.65. What is the ratio of the Trade (in US$) of Solomon Islands in 1997 to that in 2000?
Your answer should be compact. 2.1. What is the ratio of the Trade (in US$) of Uzbekistan in 1997 to that in 2000?
Your response must be concise. 1.18. What is the ratio of the Trade (in US$) of China in 1997 to that in 2001?
Keep it short and to the point. 0.69. What is the ratio of the Trade (in US$) in Moldova in 1997 to that in 2001?
Offer a very short reply. 1.43. What is the ratio of the Trade (in US$) in Solomon Islands in 1997 to that in 2001?
Keep it short and to the point. 3.32. What is the ratio of the Trade (in US$) of Uzbekistan in 1997 to that in 2001?
Provide a short and direct response. 1.25. What is the ratio of the Trade (in US$) of China in 1998 to that in 1999?
Your answer should be compact. 0.94. What is the ratio of the Trade (in US$) of Moldova in 1998 to that in 1999?
Keep it short and to the point. 1.3. What is the ratio of the Trade (in US$) in Solomon Islands in 1998 to that in 1999?
Your answer should be compact. 0.99. What is the ratio of the Trade (in US$) in Uzbekistan in 1998 to that in 1999?
Offer a terse response. 1.09. What is the ratio of the Trade (in US$) of China in 1998 to that in 2000?
Keep it short and to the point. 0.74. What is the ratio of the Trade (in US$) in Moldova in 1998 to that in 2000?
Your response must be concise. 1.24. What is the ratio of the Trade (in US$) in Solomon Islands in 1998 to that in 2000?
Offer a very short reply. 1.63. What is the ratio of the Trade (in US$) in Uzbekistan in 1998 to that in 2000?
Your response must be concise. 1. What is the ratio of the Trade (in US$) in China in 1998 to that in 2001?
Give a very brief answer. 0.69. What is the ratio of the Trade (in US$) of Moldova in 1998 to that in 2001?
Offer a very short reply. 1.08. What is the ratio of the Trade (in US$) of Solomon Islands in 1998 to that in 2001?
Ensure brevity in your answer.  2.58. What is the ratio of the Trade (in US$) in Uzbekistan in 1998 to that in 2001?
Your answer should be compact. 1.05. What is the ratio of the Trade (in US$) in China in 1999 to that in 2000?
Provide a short and direct response. 0.78. What is the ratio of the Trade (in US$) in Moldova in 1999 to that in 2000?
Provide a short and direct response. 0.95. What is the ratio of the Trade (in US$) in Solomon Islands in 1999 to that in 2000?
Make the answer very short. 1.64. What is the ratio of the Trade (in US$) of Uzbekistan in 1999 to that in 2000?
Your response must be concise. 0.92. What is the ratio of the Trade (in US$) of China in 1999 to that in 2001?
Provide a succinct answer. 0.73. What is the ratio of the Trade (in US$) in Moldova in 1999 to that in 2001?
Give a very brief answer. 0.83. What is the ratio of the Trade (in US$) of Solomon Islands in 1999 to that in 2001?
Offer a terse response. 2.6. What is the ratio of the Trade (in US$) in Uzbekistan in 1999 to that in 2001?
Give a very brief answer. 0.97. What is the ratio of the Trade (in US$) in China in 2000 to that in 2001?
Your response must be concise. 0.94. What is the ratio of the Trade (in US$) of Moldova in 2000 to that in 2001?
Make the answer very short. 0.87. What is the ratio of the Trade (in US$) of Solomon Islands in 2000 to that in 2001?
Your response must be concise. 1.59. What is the ratio of the Trade (in US$) of Uzbekistan in 2000 to that in 2001?
Your answer should be very brief. 1.06. What is the difference between the highest and the second highest Trade (in US$) of China?
Offer a very short reply. 1.68e+1. What is the difference between the highest and the second highest Trade (in US$) in Moldova?
Make the answer very short. 1.21e+08. What is the difference between the highest and the second highest Trade (in US$) in Solomon Islands?
Your answer should be compact. 2.51e+07. What is the difference between the highest and the second highest Trade (in US$) in Uzbekistan?
Provide a short and direct response. 9.10e+08. What is the difference between the highest and the lowest Trade (in US$) in China?
Offer a terse response. 1.45e+11. What is the difference between the highest and the lowest Trade (in US$) in Moldova?
Offer a terse response. 4.48e+08. What is the difference between the highest and the lowest Trade (in US$) in Solomon Islands?
Provide a succinct answer. 1.53e+08. What is the difference between the highest and the lowest Trade (in US$) of Uzbekistan?
Make the answer very short. 2.73e+09. 